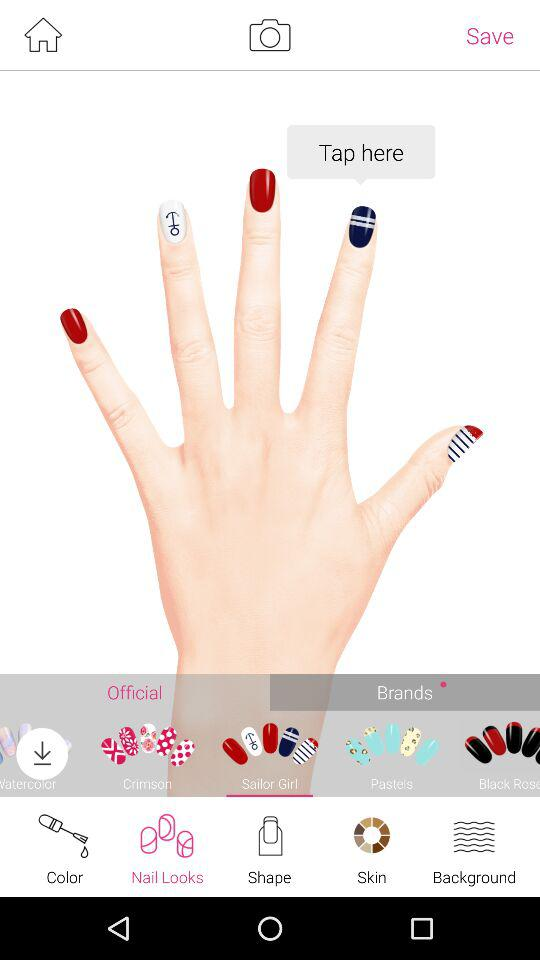Which type of brands available?
When the provided information is insufficient, respond with <no answer>. <no answer> 